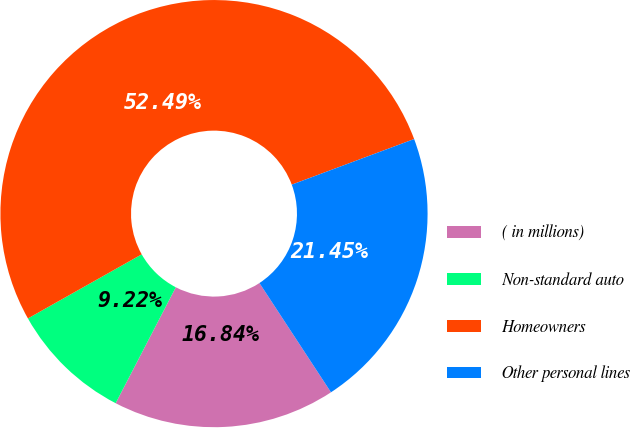Convert chart. <chart><loc_0><loc_0><loc_500><loc_500><pie_chart><fcel>( in millions)<fcel>Non-standard auto<fcel>Homeowners<fcel>Other personal lines<nl><fcel>16.84%<fcel>9.22%<fcel>52.49%<fcel>21.45%<nl></chart> 